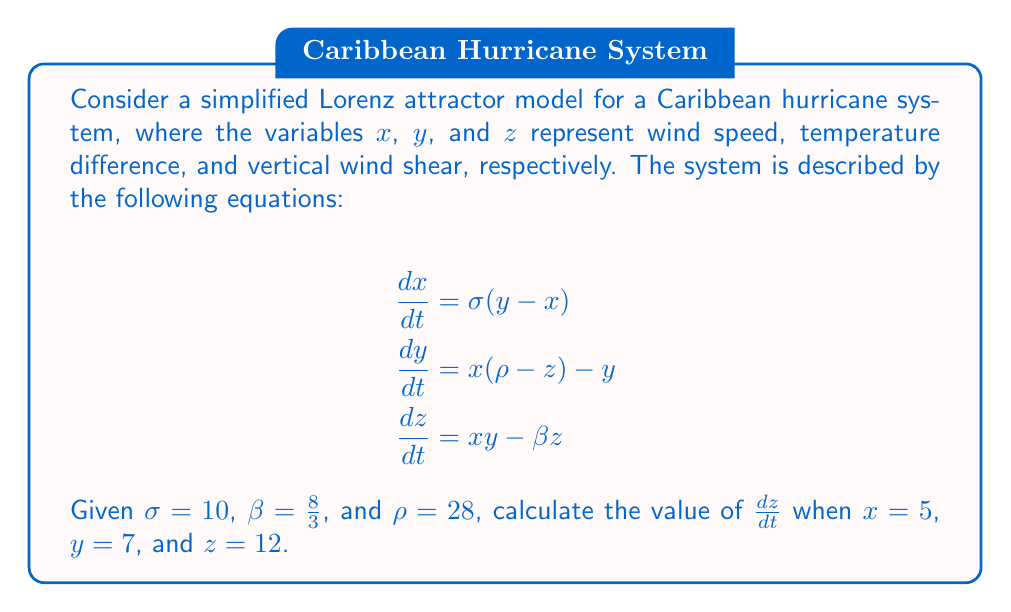Teach me how to tackle this problem. To solve this problem, we'll follow these steps:

1) We are given the equation for $\frac{dz}{dt}$:
   $$\frac{dz}{dt} = xy - \beta z$$

2) We know the values of $x$, $y$, and $z$:
   $x = 5$
   $y = 7$
   $z = 12$

3) We are also given the value of $\beta$:
   $\beta = \frac{8}{3}$

4) Let's substitute these values into the equation:
   $$\frac{dz}{dt} = (5)(7) - \frac{8}{3}(12)$$

5) First, let's calculate $xy$:
   $5 * 7 = 35$

6) Next, let's calculate $\frac{8}{3}(12)$:
   $\frac{8}{3} * 12 = 32$

7) Now we can subtract:
   $$\frac{dz}{dt} = 35 - 32 = 3$$

Therefore, the value of $\frac{dz}{dt}$ is 3.
Answer: 3 